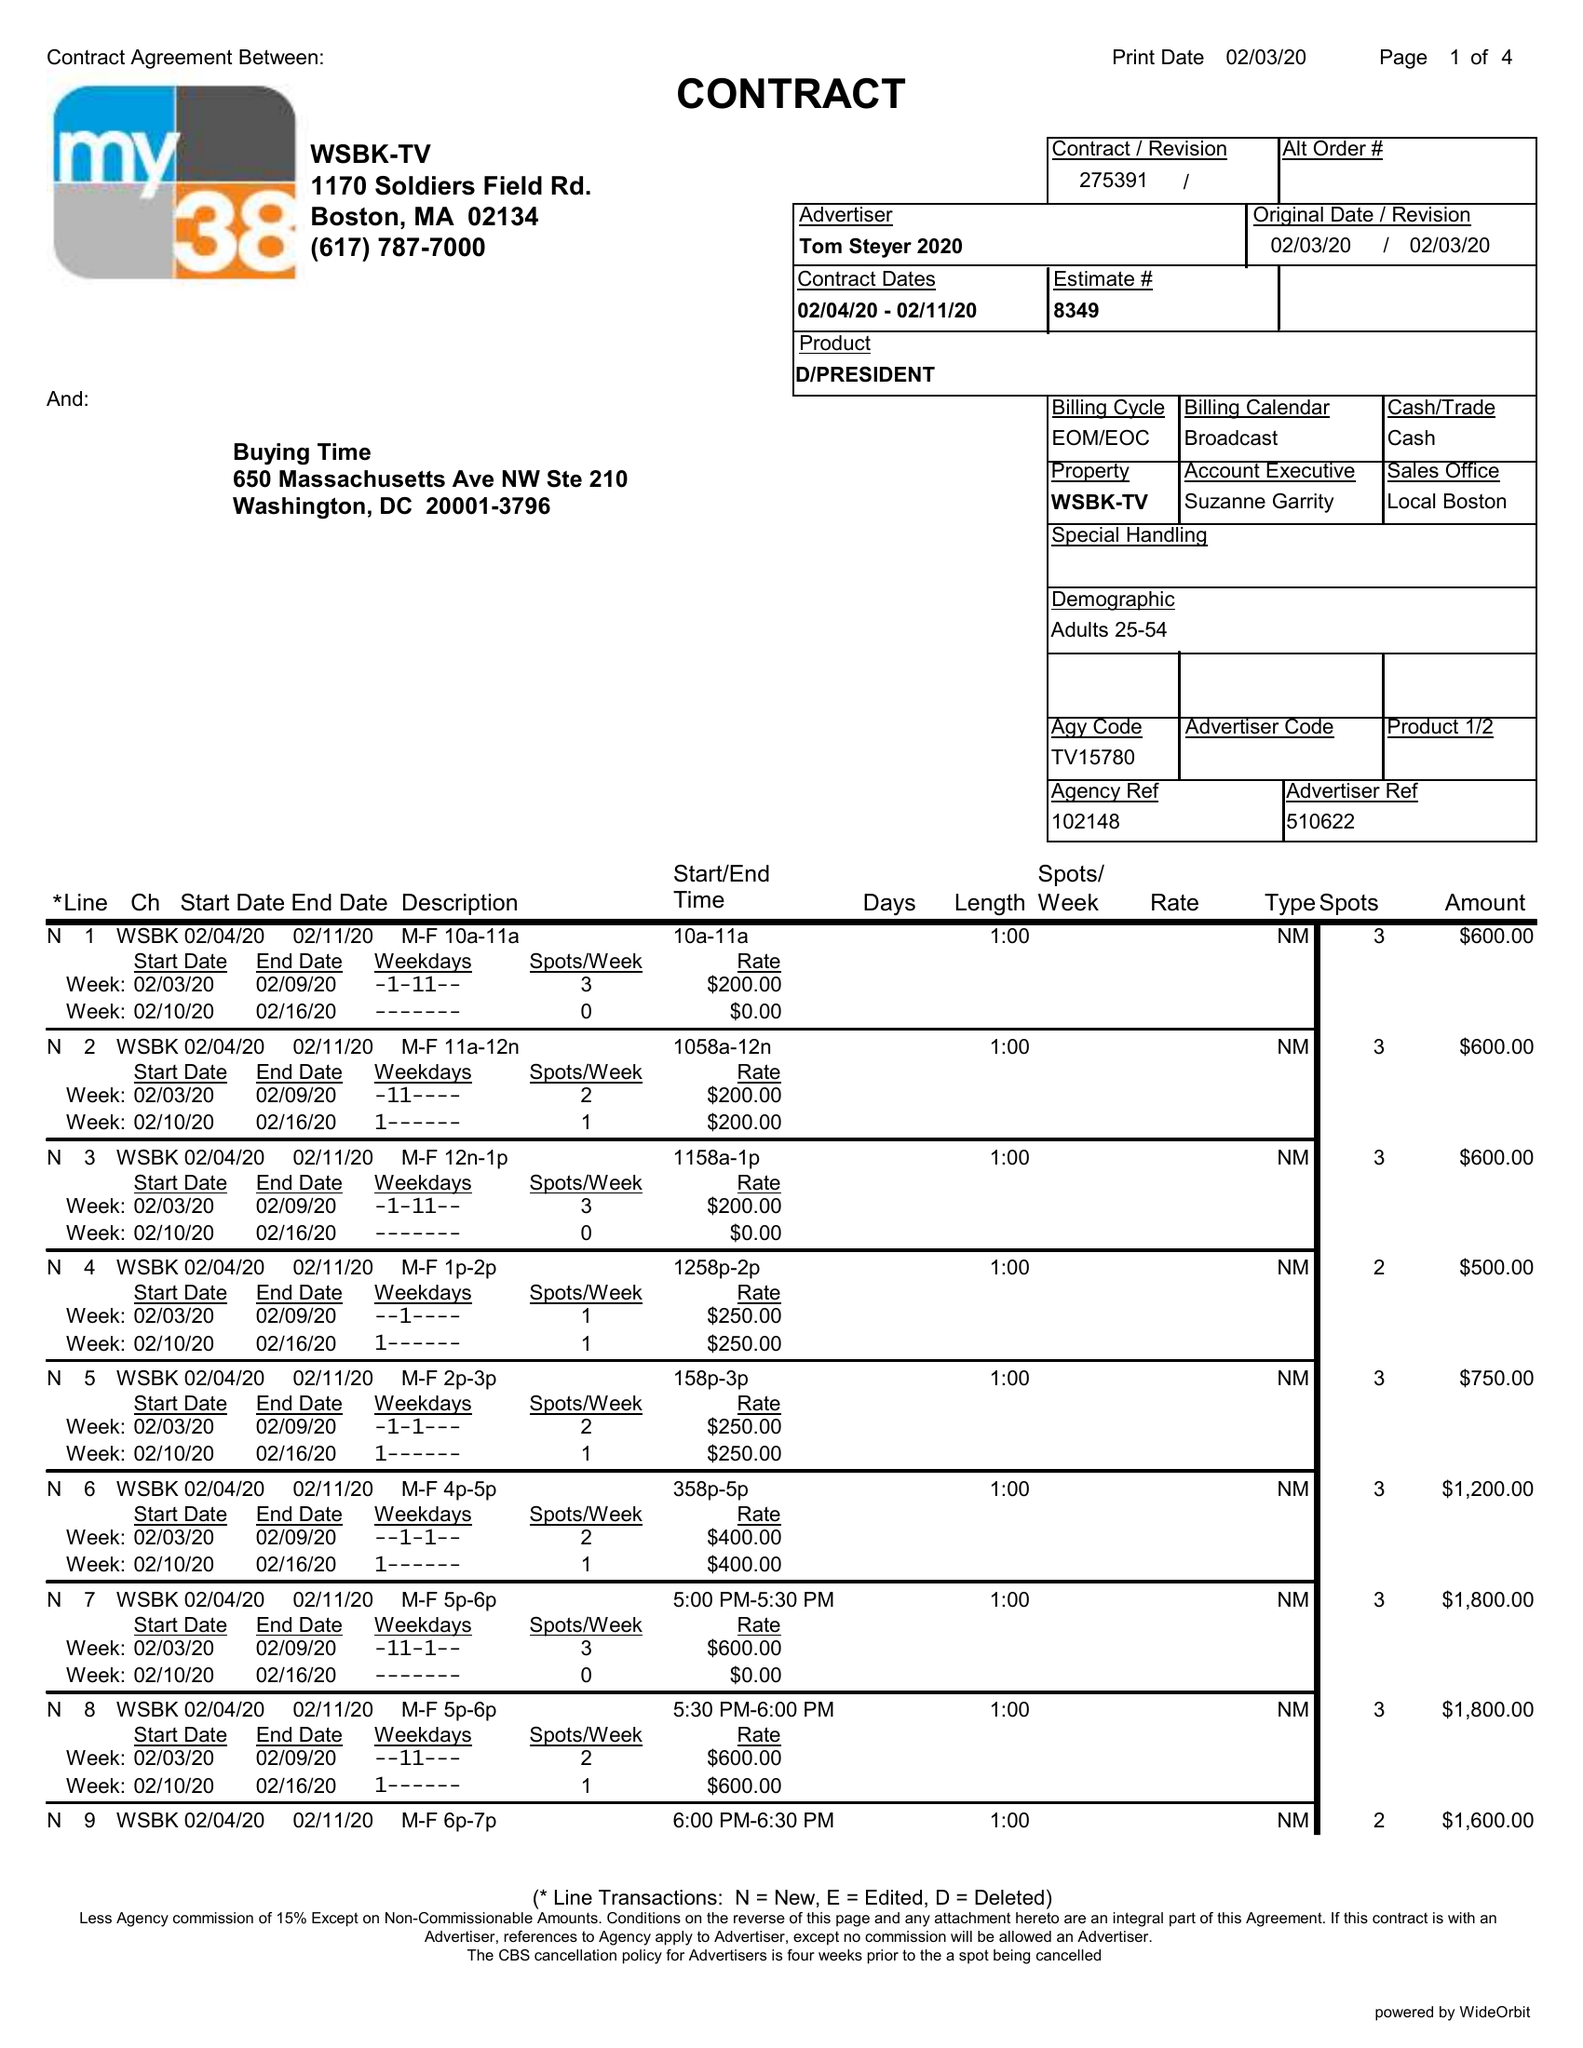What is the value for the gross_amount?
Answer the question using a single word or phrase. 21350.00 